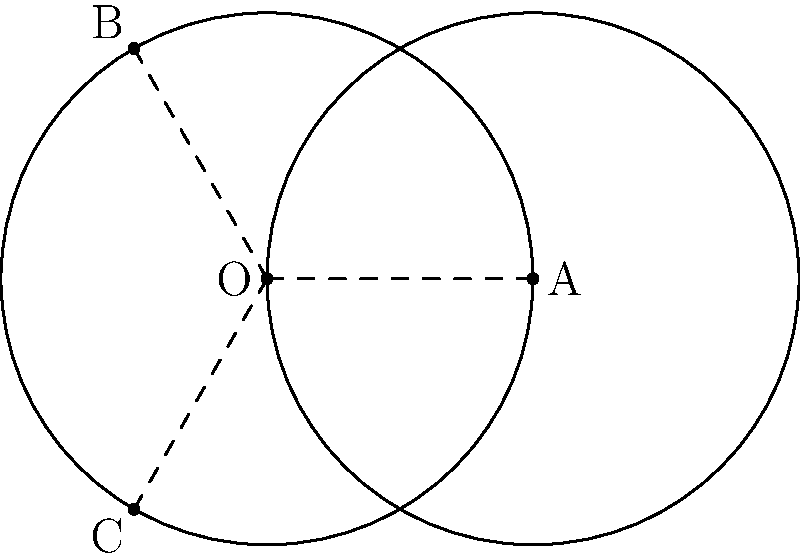During an underwater sonar mapping expedition, you detect two circular structures on the ocean floor with the same radius $r$. The centers of these circles are 2$r$ units apart. If points B and C are located where the circles intersect, what is the measure of angle BOC? Let's approach this step-by-step:

1) First, we recognize that the two circles are congruent, as they have the same radius $r$.

2) The centers of the circles (O and A) are 2$r$ units apart, which is equal to the diameter of each circle.

3) This configuration creates an equilateral triangle OAB (and OAC), where:
   - OA = 2$r$ (given)
   - OB = AB = $r$ (radii of the circles)

4) In an equilateral triangle, all angles are 60°. So, angle AOB = 60°.

5) The angle BOC is made up of two of these 60° angles.

6) Therefore, angle BOC = 60° + 60° = 120°.

This angle of 120° is a key characteristic of the intersection of two circles where the distance between their centers is equal to their diameter.
Answer: 120° 